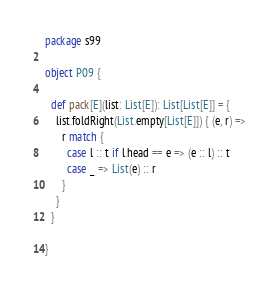Convert code to text. <code><loc_0><loc_0><loc_500><loc_500><_Scala_>package s99

object P09 {

  def pack[E](list: List[E]): List[List[E]] = {
    list.foldRight(List.empty[List[E]]) { (e, r) =>
      r match {
        case l :: t if l.head == e => (e :: l) :: t
        case _ => List(e) :: r
      }
    }
  }

}
</code> 